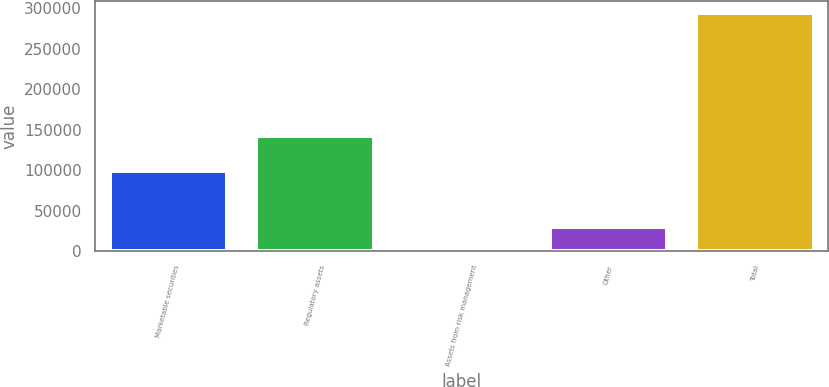Convert chart. <chart><loc_0><loc_0><loc_500><loc_500><bar_chart><fcel>Marketable securities<fcel>Regulatory assets<fcel>Assets from risk management<fcel>Other<fcel>Total<nl><fcel>99385<fcel>141778<fcel>250<fcel>29626.8<fcel>294018<nl></chart> 